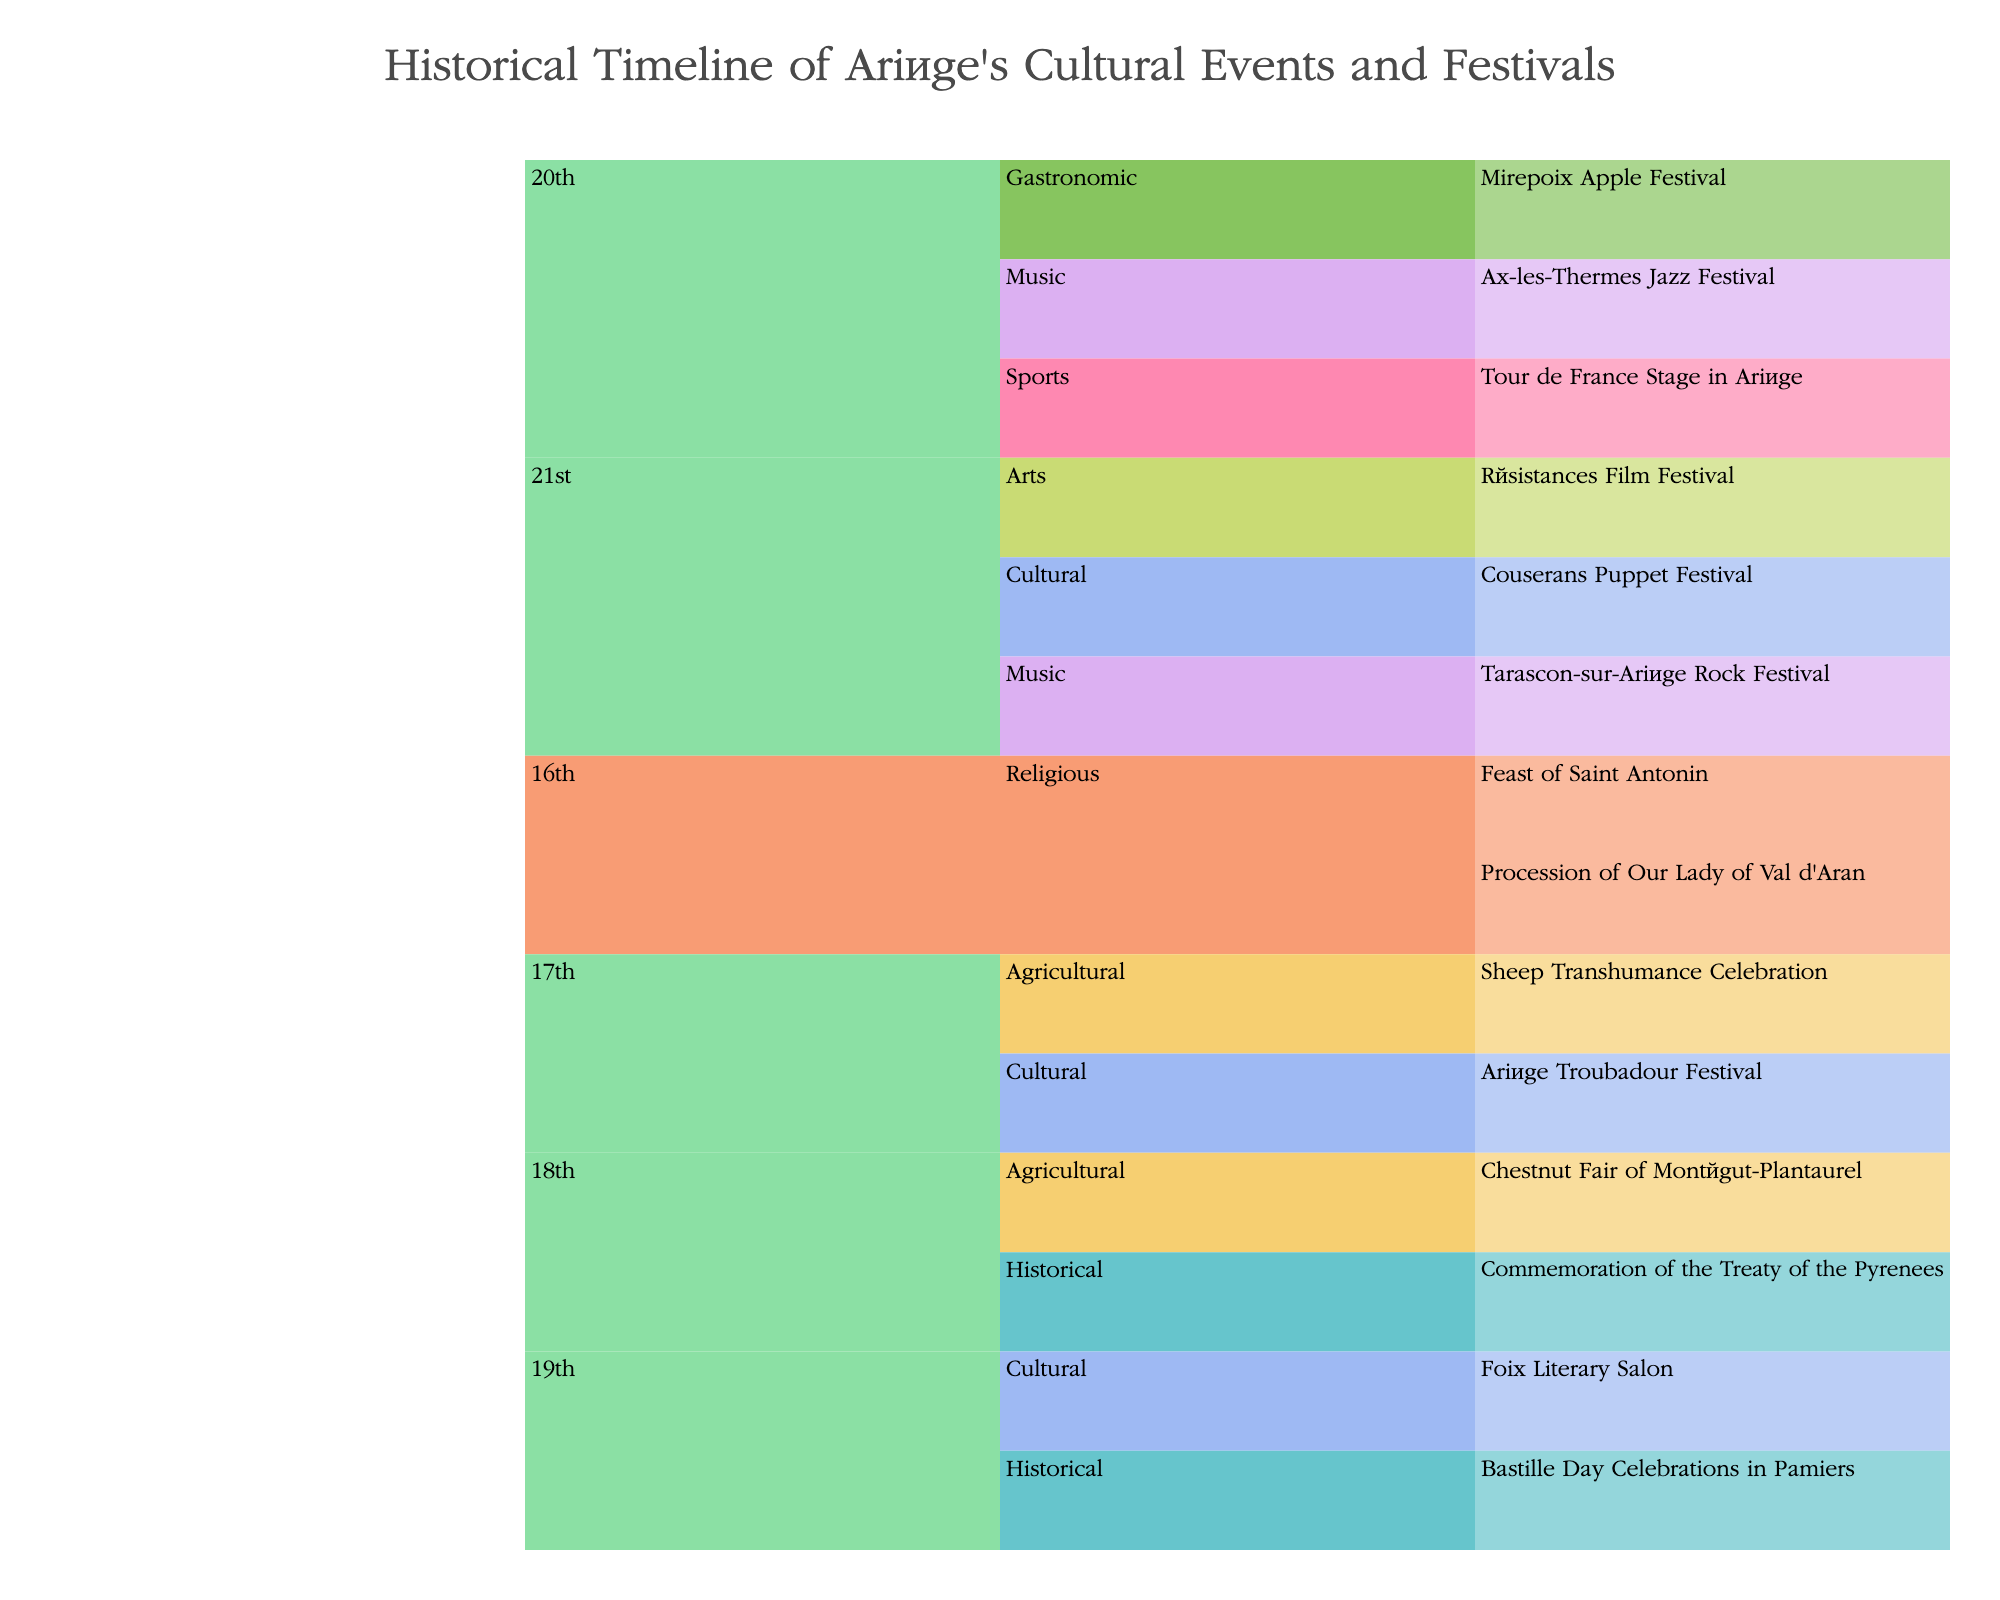What's the title of the chart? The title of the chart is usually the most prominent text and is located at the top of the plot.
Answer: Historical Timeline of Ariège's Cultural Events and Festivals In which century are the most types of events represented? Look at each century in the plot and count the number of event types. The 20th and 21st centuries have the most, with three event types each.
Answer: 20th century and 21st century How many events are listed under 18th century? Navigate through the plot to find the 18th century, then count the individual events listed. There are two events: Commemoration of the Treaty of the Pyrenees and Chestnut Fair of Montégut-Plantaurel.
Answer: 2 Which event types are present in the 21st century? In the 21st century section of the plot, identify the distinct event types. They are Arts, Cultural, and Music.
Answer: Arts, Cultural, Music What is the only Sports event on the chart? Find the event type "Sports," which has only one event listed under it: the Tour de France Stage in Ariège.
Answer: Tour de France Stage in Ariège Which century hosts the most agricultural events? Scan each century, sum the agricultural events, and identify which century has the highest count. The 17th and 18th centuries each have one agricultural event.
Answer: 17th and 18th centuries equally Is there a century represented that does not feature any cultural events? Check each century to see if any lack the Cultural event type. Both the 16th and 18th centuries do not have Cultural events.
Answer: 16th and 18th centuries Which music event took place in the 20th century? Navigate to the 20th-century section and look for events listed under the Music event type. The Ax-les-Thermes Jazz Festival is the music event there.
Answer: Ax-les-Thermes Jazz Festival How does the number of Festivals in the 19th century compare to those in the 21st century? Count the number of events listed under the 19th century and compare it to the count under the 21st century. The 19th century has 2 events, while the 21st century has 3 events.
Answer: Fewer in the 19th century How many artistic events are included in the chart? Search for events categorized under the Arts event type within the entire chart. There is only one such event: the Résistances Film Festival.
Answer: 1 